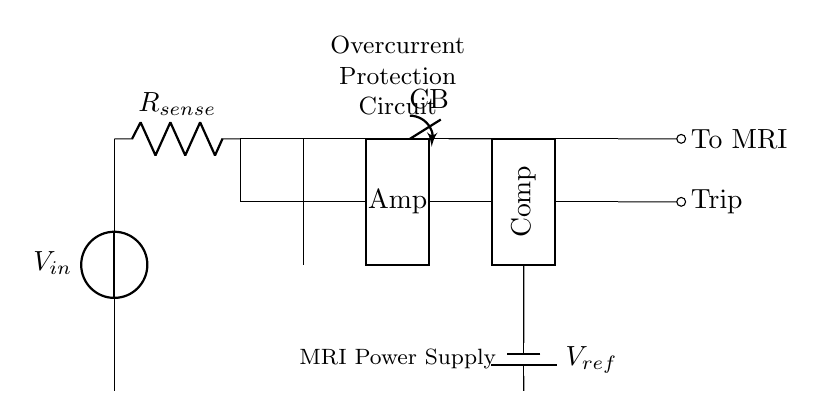What is the type of the power source in this circuit? The power source is a voltage source, which is represented by the symbol for the voltage source in the diagram at the top left corner of the circuit. It provides the necessary voltage for the power supply.
Answer: Voltage source What component is used to sense current in this circuit? The current sensing component is a resistor, labeled as R sense in the diagram. It allows for measuring the current flowing through the circuit by monitoring the voltage drop across it.
Answer: Resistor What is the role of the comparator in this circuit? The comparator is used to compare the output from the current sensing amplifier with a reference voltage. It will output a signal that indicates whether the current exceeds a set threshold, which initiates the trip signal to the circuit breaker if necessary.
Answer: Compare current Which component is responsible for interrupting the circuit during an overcurrent condition? The circuit breaker, labeled as CB in the diagram, interrupts the current flow when the trip signal is activated, protecting the downstream components from damage due to excessive current.
Answer: Circuit breaker What does the reference voltage represent in this circuit? The reference voltage, labeled as V ref, serves as a threshold level against which the sensed current voltage is compared. If the current exceeds this reference, the comparator outputs a trip signal.
Answer: Threshold level How is the trip signal triggered in this circuit? The trip signal is triggered when the voltage from the current sensing amplifier exceeds the reference voltage established by V ref, which is detected by the comparator leading to the activation of the circuit breaker.
Answer: By comparator action What is the primary function of this overcurrent protection circuit? The primary function is to protect the MRI machine from damage by interrupting the power supply in the event of an overcurrent condition, thus ensuring safe operation.
Answer: Overcurrent protection 